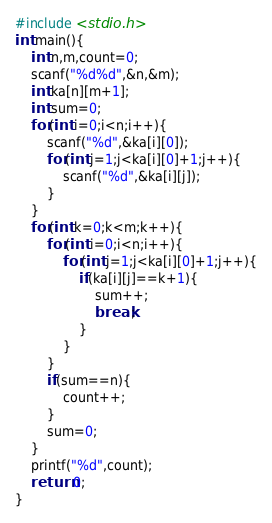Convert code to text. <code><loc_0><loc_0><loc_500><loc_500><_C_>#include <stdio.h>
int main(){
    int n,m,count=0;
    scanf("%d%d",&n,&m);
    int ka[n][m+1];
    int sum=0;
    for(int i=0;i<n;i++){
        scanf("%d",&ka[i][0]);
        for(int j=1;j<ka[i][0]+1;j++){
            scanf("%d",&ka[i][j]);
        }
    }
    for(int k=0;k<m;k++){
        for(int i=0;i<n;i++){
            for(int j=1;j<ka[i][0]+1;j++){
                if(ka[i][j]==k+1){
                    sum++;
                    break;
                }
            }
        }
        if(sum==n){
            count++;
        }
        sum=0;
    }
    printf("%d",count);
    return 0;
}</code> 